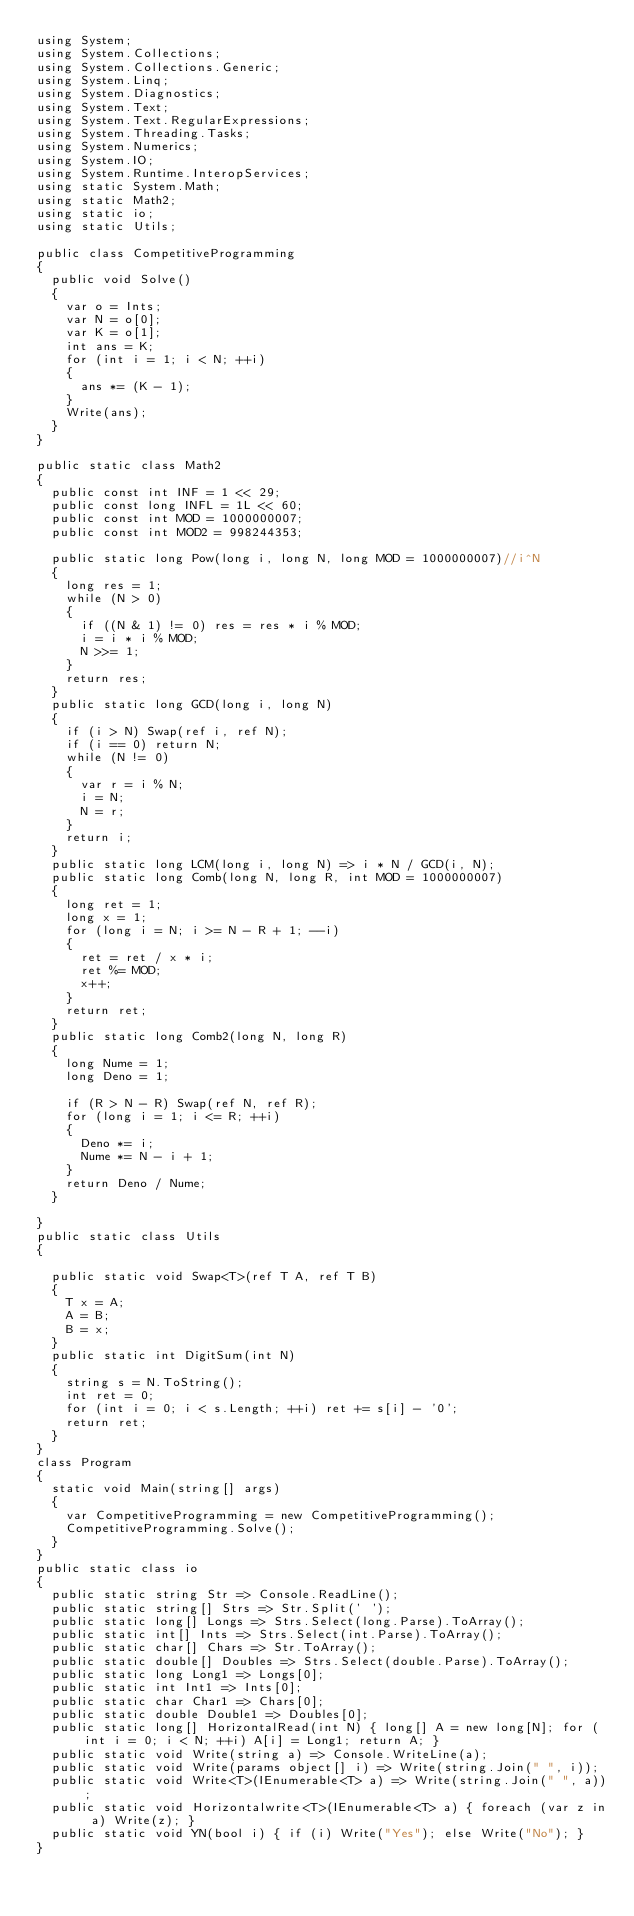Convert code to text. <code><loc_0><loc_0><loc_500><loc_500><_C#_>using System;
using System.Collections;
using System.Collections.Generic;
using System.Linq;
using System.Diagnostics;
using System.Text;
using System.Text.RegularExpressions;
using System.Threading.Tasks;
using System.Numerics;
using System.IO;
using System.Runtime.InteropServices;
using static System.Math;
using static Math2;
using static io;
using static Utils;

public class CompetitiveProgramming
{
  public void Solve()
  {
    var o = Ints;
    var N = o[0];
    var K = o[1];
    int ans = K;
    for (int i = 1; i < N; ++i)
    {
      ans *= (K - 1);
    }
    Write(ans);
  }
}

public static class Math2
{
  public const int INF = 1 << 29;
  public const long INFL = 1L << 60;
  public const int MOD = 1000000007;
  public const int MOD2 = 998244353;

  public static long Pow(long i, long N, long MOD = 1000000007)//i^N
  {
    long res = 1;
    while (N > 0)
    {
      if ((N & 1) != 0) res = res * i % MOD;
      i = i * i % MOD;
      N >>= 1;
    }
    return res;
  }
  public static long GCD(long i, long N)
  {
    if (i > N) Swap(ref i, ref N);
    if (i == 0) return N;
    while (N != 0)
    {
      var r = i % N;
      i = N;
      N = r;
    }
    return i;
  }
  public static long LCM(long i, long N) => i * N / GCD(i, N);
  public static long Comb(long N, long R, int MOD = 1000000007)
  {
    long ret = 1;
    long x = 1;
    for (long i = N; i >= N - R + 1; --i)
    {
      ret = ret / x * i;
      ret %= MOD;
      x++;
    }
    return ret;
  }
  public static long Comb2(long N, long R)
  {
    long Nume = 1;
    long Deno = 1;

    if (R > N - R) Swap(ref N, ref R);
    for (long i = 1; i <= R; ++i)
    {
      Deno *= i;
      Nume *= N - i + 1;
    }
    return Deno / Nume;
  }

}
public static class Utils
{

  public static void Swap<T>(ref T A, ref T B)
  {
    T x = A;
    A = B;
    B = x;
  }
  public static int DigitSum(int N)
  {
    string s = N.ToString();
    int ret = 0;
    for (int i = 0; i < s.Length; ++i) ret += s[i] - '0';
    return ret;
  }
}
class Program
{
  static void Main(string[] args)
  {
    var CompetitiveProgramming = new CompetitiveProgramming();
    CompetitiveProgramming.Solve();
  }
}
public static class io
{
  public static string Str => Console.ReadLine();
  public static string[] Strs => Str.Split(' ');
  public static long[] Longs => Strs.Select(long.Parse).ToArray();
  public static int[] Ints => Strs.Select(int.Parse).ToArray();
  public static char[] Chars => Str.ToArray();
  public static double[] Doubles => Strs.Select(double.Parse).ToArray();
  public static long Long1 => Longs[0];
  public static int Int1 => Ints[0];
  public static char Char1 => Chars[0];
  public static double Double1 => Doubles[0];
  public static long[] HorizontalRead(int N) { long[] A = new long[N]; for (int i = 0; i < N; ++i) A[i] = Long1; return A; }
  public static void Write(string a) => Console.WriteLine(a);
  public static void Write(params object[] i) => Write(string.Join(" ", i));
  public static void Write<T>(IEnumerable<T> a) => Write(string.Join(" ", a));
  public static void Horizontalwrite<T>(IEnumerable<T> a) { foreach (var z in a) Write(z); }
  public static void YN(bool i) { if (i) Write("Yes"); else Write("No"); }
}
</code> 